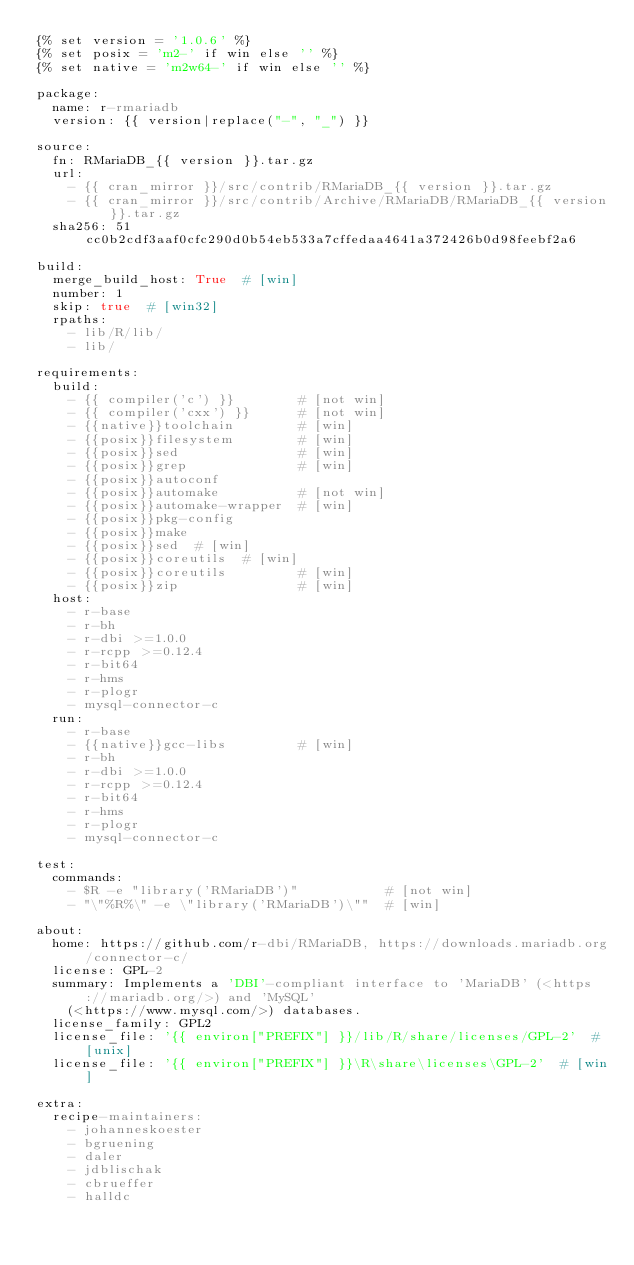Convert code to text. <code><loc_0><loc_0><loc_500><loc_500><_YAML_>{% set version = '1.0.6' %}
{% set posix = 'm2-' if win else '' %}
{% set native = 'm2w64-' if win else '' %}

package:
  name: r-rmariadb
  version: {{ version|replace("-", "_") }}

source:
  fn: RMariaDB_{{ version }}.tar.gz
  url:
    - {{ cran_mirror }}/src/contrib/RMariaDB_{{ version }}.tar.gz
    - {{ cran_mirror }}/src/contrib/Archive/RMariaDB/RMariaDB_{{ version }}.tar.gz
  sha256: 51cc0b2cdf3aaf0cfc290d0b54eb533a7cffedaa4641a372426b0d98feebf2a6

build:
  merge_build_host: True  # [win]
  number: 1
  skip: true  # [win32]
  rpaths:
    - lib/R/lib/
    - lib/

requirements:
  build:
    - {{ compiler('c') }}        # [not win]
    - {{ compiler('cxx') }}      # [not win]
    - {{native}}toolchain        # [win]
    - {{posix}}filesystem        # [win]
    - {{posix}}sed               # [win]
    - {{posix}}grep              # [win]
    - {{posix}}autoconf
    - {{posix}}automake          # [not win]
    - {{posix}}automake-wrapper  # [win]
    - {{posix}}pkg-config
    - {{posix}}make
    - {{posix}}sed  # [win]
    - {{posix}}coreutils  # [win]
    - {{posix}}coreutils         # [win]
    - {{posix}}zip               # [win]
  host:
    - r-base
    - r-bh
    - r-dbi >=1.0.0
    - r-rcpp >=0.12.4
    - r-bit64
    - r-hms
    - r-plogr
    - mysql-connector-c
  run:
    - r-base
    - {{native}}gcc-libs         # [win]
    - r-bh
    - r-dbi >=1.0.0
    - r-rcpp >=0.12.4
    - r-bit64
    - r-hms
    - r-plogr
    - mysql-connector-c

test:
  commands:
    - $R -e "library('RMariaDB')"           # [not win]
    - "\"%R%\" -e \"library('RMariaDB')\""  # [win]

about:
  home: https://github.com/r-dbi/RMariaDB, https://downloads.mariadb.org/connector-c/
  license: GPL-2
  summary: Implements a 'DBI'-compliant interface to 'MariaDB' (<https://mariadb.org/>) and 'MySQL'
    (<https://www.mysql.com/>) databases.
  license_family: GPL2
  license_file: '{{ environ["PREFIX"] }}/lib/R/share/licenses/GPL-2'  # [unix]
  license_file: '{{ environ["PREFIX"] }}\R\share\licenses\GPL-2'  # [win]

extra:
  recipe-maintainers:
    - johanneskoester
    - bgruening
    - daler
    - jdblischak
    - cbrueffer
    - halldc
</code> 